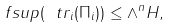<formula> <loc_0><loc_0><loc_500><loc_500>\ f s u p ( \ t r _ { i } ( \Pi _ { i } ) ) \leq { \wedge } ^ { n } H ,</formula> 